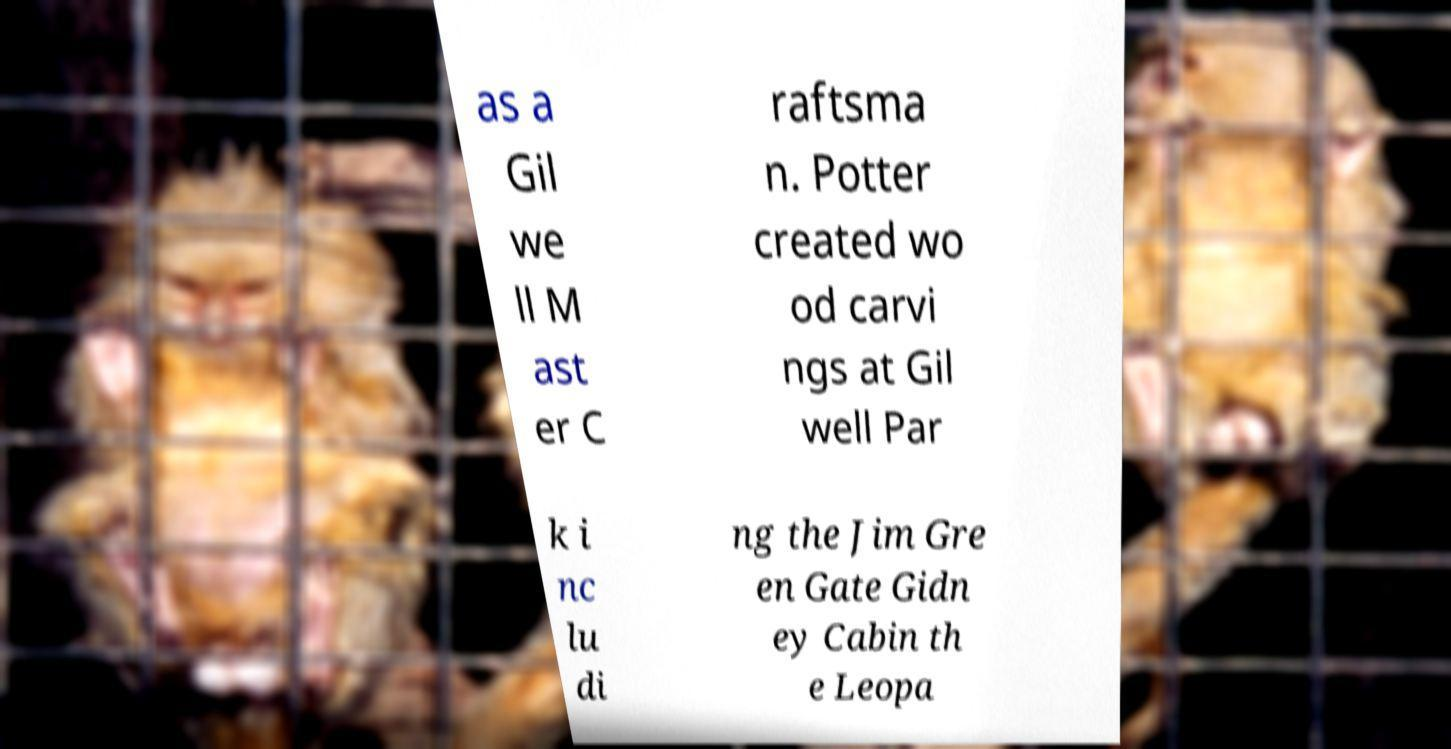What messages or text are displayed in this image? I need them in a readable, typed format. as a Gil we ll M ast er C raftsma n. Potter created wo od carvi ngs at Gil well Par k i nc lu di ng the Jim Gre en Gate Gidn ey Cabin th e Leopa 